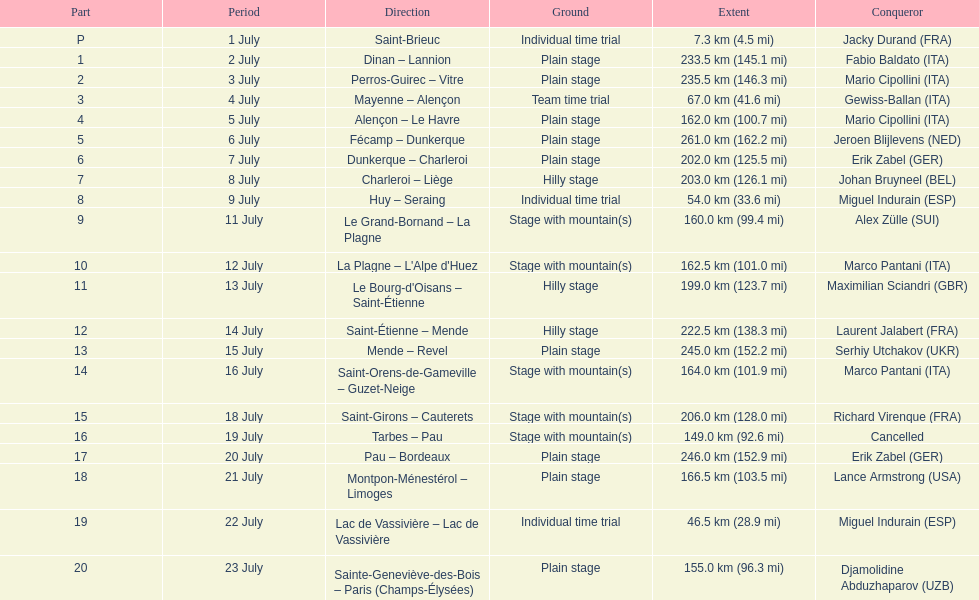Which courses were no less than 100 km? Dinan - Lannion, Perros-Guirec - Vitre, Alençon - Le Havre, Fécamp - Dunkerque, Dunkerque - Charleroi, Charleroi - Liège, Le Grand-Bornand - La Plagne, La Plagne - L'Alpe d'Huez, Le Bourg-d'Oisans - Saint-Étienne, Saint-Étienne - Mende, Mende - Revel, Saint-Orens-de-Gameville - Guzet-Neige, Saint-Girons - Cauterets, Tarbes - Pau, Pau - Bordeaux, Montpon-Ménestérol - Limoges, Sainte-Geneviève-des-Bois - Paris (Champs-Élysées). 